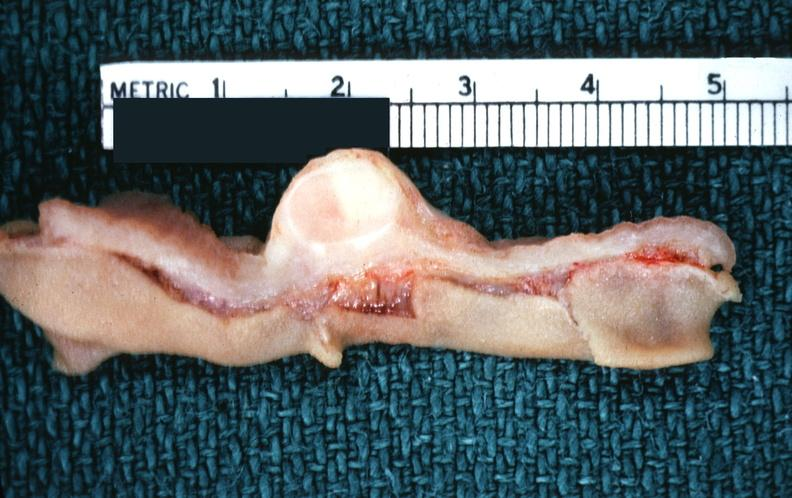does this image show stomach, leiomyoma with ulcerated mucosal surface?
Answer the question using a single word or phrase. Yes 